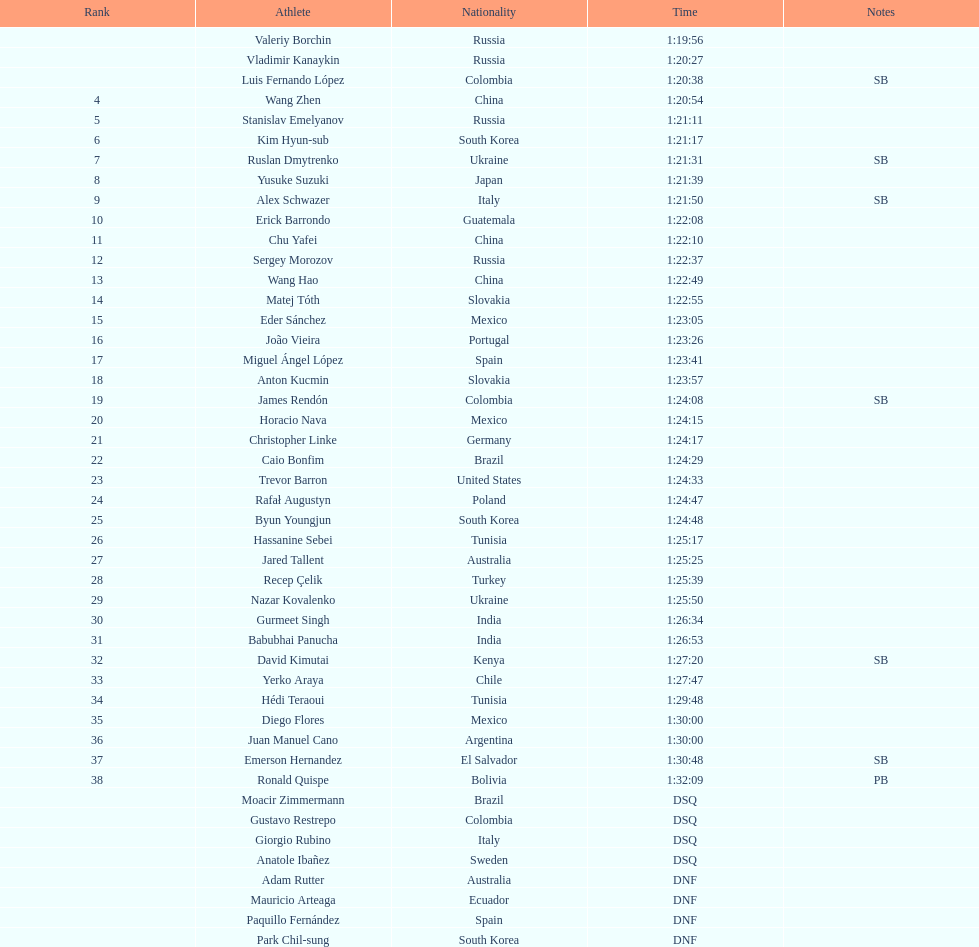Who placed in the top spot? Valeriy Borchin. 